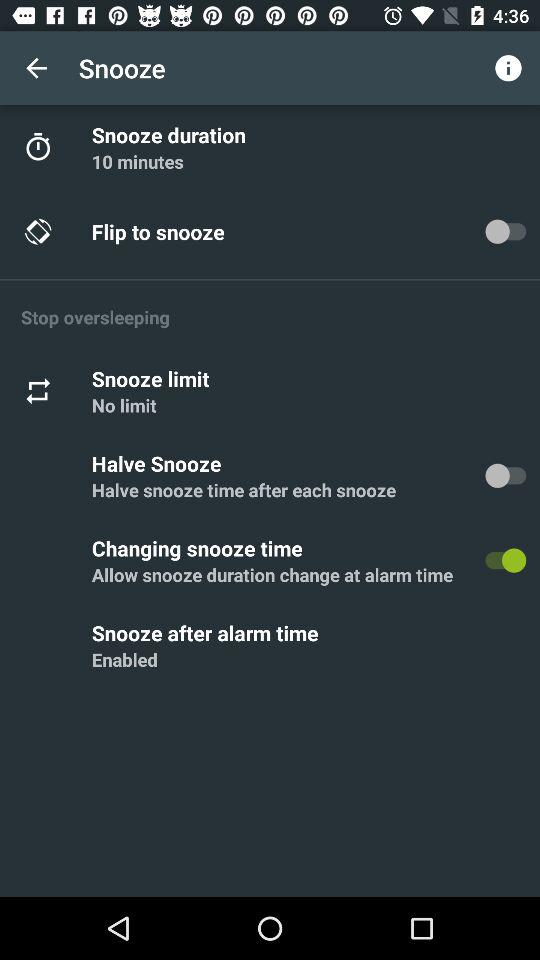What is the snooze duration? The snooze duration is 10 minutes. 